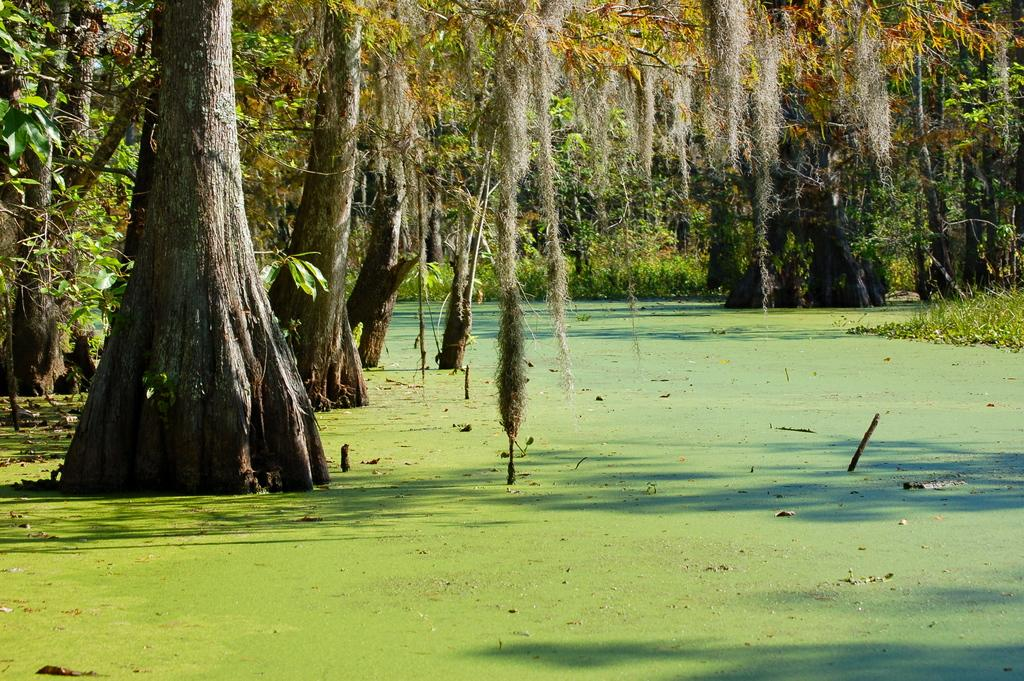What type of vegetation is present in the image? There are many trees in the image. What else can be seen on the ground in the image? There is grass in the image. How are the trees and grass arranged in the image? The green surface, which includes the grass, is surrounded by trees and grass. How many goldfish can be seen swimming in the grass in the image? There are no goldfish present in the image; it features trees and grass. What type of apparel is being worn by the trees in the image? Trees do not wear apparel, as they are plants and not people. 